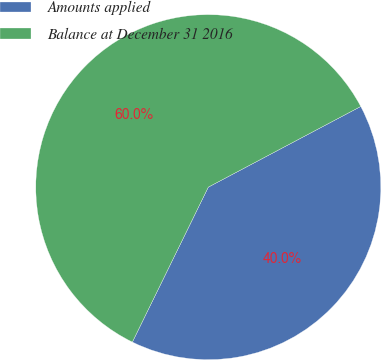Convert chart. <chart><loc_0><loc_0><loc_500><loc_500><pie_chart><fcel>Amounts applied<fcel>Balance at December 31 2016<nl><fcel>40.0%<fcel>60.0%<nl></chart> 